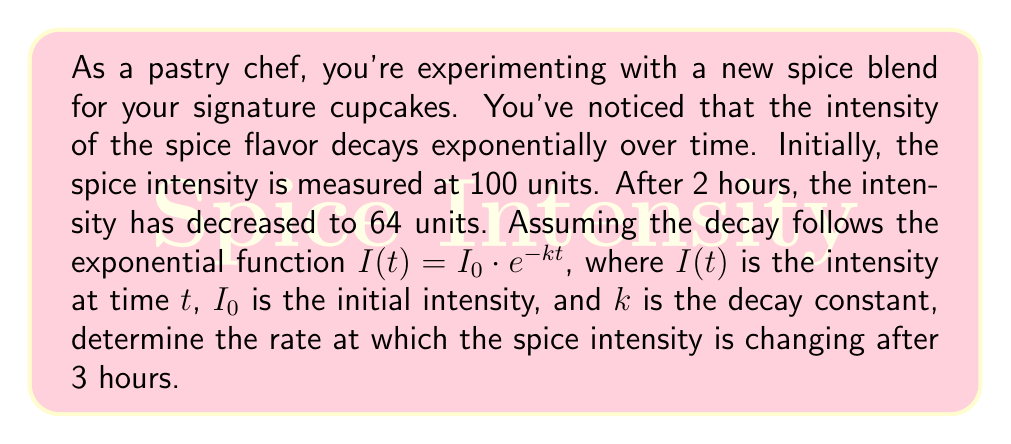Solve this math problem. Let's approach this step-by-step:

1) We're given the exponential decay function: $I(t) = I_0 \cdot e^{-kt}$

2) We know:
   - Initial intensity $I_0 = 100$ units
   - After 2 hours, intensity $I(2) = 64$ units

3) Let's find the decay constant $k$:
   
   $64 = 100 \cdot e^{-2k}$
   
   $\frac{64}{100} = e^{-2k}$
   
   $\ln(0.64) = -2k$
   
   $k = -\frac{\ln(0.64)}{2} \approx 0.2231$

4) Now we have our complete function:
   
   $I(t) = 100 \cdot e^{-0.2231t}$

5) To find the rate of change at 3 hours, we need to find the derivative of $I(t)$ and evaluate it at $t=3$:
   
   $\frac{dI}{dt} = -0.2231 \cdot 100 \cdot e^{-0.2231t}$
   
   $\frac{dI}{dt} = -22.31 \cdot e^{-0.2231t}$

6) Evaluate at $t=3$:
   
   $\frac{dI}{dt}|_{t=3} = -22.31 \cdot e^{-0.2231 \cdot 3}$
   
   $= -22.31 \cdot e^{-0.6693}$
   
   $\approx -11.37$

The negative sign indicates that the intensity is decreasing.
Answer: The rate at which the spice intensity is changing after 3 hours is approximately -11.37 units per hour. 